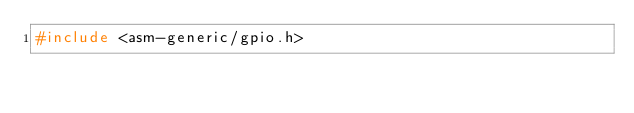<code> <loc_0><loc_0><loc_500><loc_500><_C_>#include <asm-generic/gpio.h>
</code> 